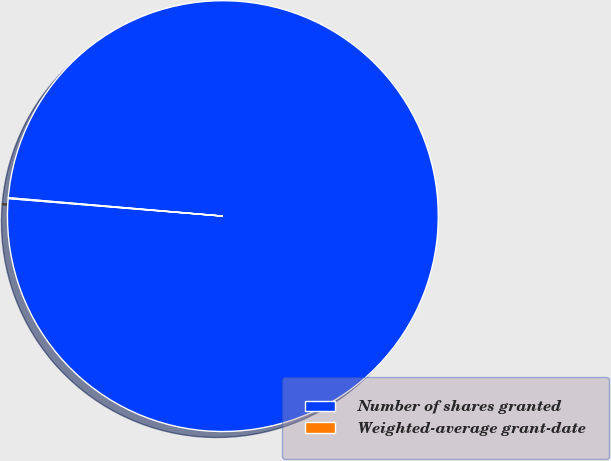Convert chart to OTSL. <chart><loc_0><loc_0><loc_500><loc_500><pie_chart><fcel>Number of shares granted<fcel>Weighted-average grant-date<nl><fcel>99.94%<fcel>0.06%<nl></chart> 